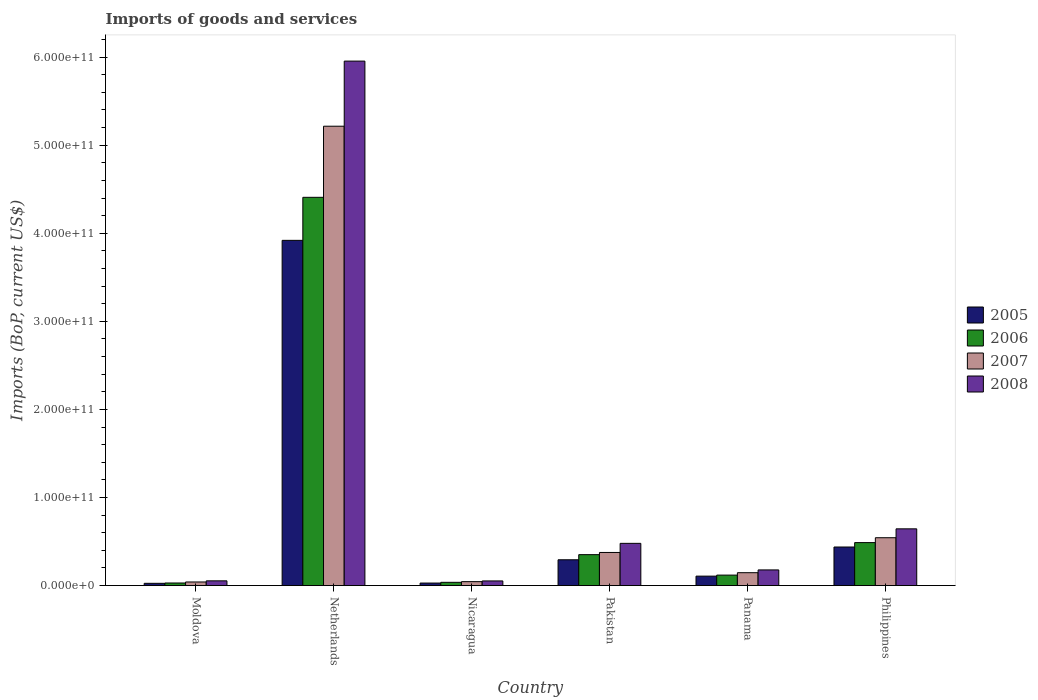How many different coloured bars are there?
Give a very brief answer. 4. How many groups of bars are there?
Make the answer very short. 6. Are the number of bars per tick equal to the number of legend labels?
Offer a terse response. Yes. How many bars are there on the 2nd tick from the left?
Keep it short and to the point. 4. What is the label of the 1st group of bars from the left?
Provide a short and direct response. Moldova. What is the amount spent on imports in 2008 in Panama?
Offer a very short reply. 1.78e+1. Across all countries, what is the maximum amount spent on imports in 2007?
Make the answer very short. 5.22e+11. Across all countries, what is the minimum amount spent on imports in 2006?
Provide a short and direct response. 2.93e+09. In which country was the amount spent on imports in 2008 minimum?
Provide a succinct answer. Nicaragua. What is the total amount spent on imports in 2008 in the graph?
Your response must be concise. 7.36e+11. What is the difference between the amount spent on imports in 2006 in Pakistan and that in Panama?
Keep it short and to the point. 2.32e+1. What is the difference between the amount spent on imports in 2006 in Philippines and the amount spent on imports in 2007 in Pakistan?
Ensure brevity in your answer.  1.12e+1. What is the average amount spent on imports in 2005 per country?
Your answer should be compact. 8.02e+1. What is the difference between the amount spent on imports of/in 2006 and amount spent on imports of/in 2007 in Pakistan?
Keep it short and to the point. -2.49e+09. In how many countries, is the amount spent on imports in 2005 greater than 20000000000 US$?
Offer a very short reply. 3. What is the ratio of the amount spent on imports in 2007 in Netherlands to that in Philippines?
Give a very brief answer. 9.6. Is the amount spent on imports in 2008 in Netherlands less than that in Philippines?
Make the answer very short. No. Is the difference between the amount spent on imports in 2006 in Netherlands and Nicaragua greater than the difference between the amount spent on imports in 2007 in Netherlands and Nicaragua?
Keep it short and to the point. No. What is the difference between the highest and the second highest amount spent on imports in 2008?
Give a very brief answer. 5.31e+11. What is the difference between the highest and the lowest amount spent on imports in 2006?
Your answer should be very brief. 4.38e+11. Is the sum of the amount spent on imports in 2005 in Moldova and Netherlands greater than the maximum amount spent on imports in 2008 across all countries?
Make the answer very short. No. Is it the case that in every country, the sum of the amount spent on imports in 2008 and amount spent on imports in 2005 is greater than the sum of amount spent on imports in 2006 and amount spent on imports in 2007?
Keep it short and to the point. No. What does the 3rd bar from the left in Philippines represents?
Your answer should be compact. 2007. What does the 4th bar from the right in Moldova represents?
Keep it short and to the point. 2005. Is it the case that in every country, the sum of the amount spent on imports in 2005 and amount spent on imports in 2007 is greater than the amount spent on imports in 2008?
Offer a terse response. Yes. How many bars are there?
Your answer should be compact. 24. How many countries are there in the graph?
Ensure brevity in your answer.  6. What is the difference between two consecutive major ticks on the Y-axis?
Offer a terse response. 1.00e+11. Are the values on the major ticks of Y-axis written in scientific E-notation?
Your response must be concise. Yes. Does the graph contain any zero values?
Your answer should be very brief. No. How many legend labels are there?
Provide a succinct answer. 4. How are the legend labels stacked?
Provide a succinct answer. Vertical. What is the title of the graph?
Make the answer very short. Imports of goods and services. What is the label or title of the X-axis?
Give a very brief answer. Country. What is the label or title of the Y-axis?
Provide a short and direct response. Imports (BoP, current US$). What is the Imports (BoP, current US$) of 2005 in Moldova?
Your answer should be compact. 2.54e+09. What is the Imports (BoP, current US$) of 2006 in Moldova?
Your response must be concise. 2.93e+09. What is the Imports (BoP, current US$) of 2007 in Moldova?
Offer a terse response. 4.07e+09. What is the Imports (BoP, current US$) in 2008 in Moldova?
Give a very brief answer. 5.37e+09. What is the Imports (BoP, current US$) in 2005 in Netherlands?
Ensure brevity in your answer.  3.92e+11. What is the Imports (BoP, current US$) in 2006 in Netherlands?
Offer a terse response. 4.41e+11. What is the Imports (BoP, current US$) in 2007 in Netherlands?
Your answer should be very brief. 5.22e+11. What is the Imports (BoP, current US$) of 2008 in Netherlands?
Make the answer very short. 5.95e+11. What is the Imports (BoP, current US$) in 2005 in Nicaragua?
Keep it short and to the point. 2.85e+09. What is the Imports (BoP, current US$) in 2006 in Nicaragua?
Offer a very short reply. 3.68e+09. What is the Imports (BoP, current US$) in 2007 in Nicaragua?
Provide a short and direct response. 4.45e+09. What is the Imports (BoP, current US$) of 2008 in Nicaragua?
Give a very brief answer. 5.26e+09. What is the Imports (BoP, current US$) in 2005 in Pakistan?
Make the answer very short. 2.93e+1. What is the Imports (BoP, current US$) in 2006 in Pakistan?
Your answer should be compact. 3.51e+1. What is the Imports (BoP, current US$) of 2007 in Pakistan?
Provide a succinct answer. 3.76e+1. What is the Imports (BoP, current US$) in 2008 in Pakistan?
Offer a terse response. 4.79e+1. What is the Imports (BoP, current US$) in 2005 in Panama?
Ensure brevity in your answer.  1.07e+1. What is the Imports (BoP, current US$) of 2006 in Panama?
Ensure brevity in your answer.  1.19e+1. What is the Imports (BoP, current US$) in 2007 in Panama?
Provide a succinct answer. 1.46e+1. What is the Imports (BoP, current US$) in 2008 in Panama?
Your answer should be compact. 1.78e+1. What is the Imports (BoP, current US$) in 2005 in Philippines?
Provide a succinct answer. 4.38e+1. What is the Imports (BoP, current US$) in 2006 in Philippines?
Your response must be concise. 4.88e+1. What is the Imports (BoP, current US$) in 2007 in Philippines?
Your answer should be compact. 5.43e+1. What is the Imports (BoP, current US$) in 2008 in Philippines?
Your answer should be very brief. 6.44e+1. Across all countries, what is the maximum Imports (BoP, current US$) of 2005?
Your answer should be compact. 3.92e+11. Across all countries, what is the maximum Imports (BoP, current US$) in 2006?
Provide a short and direct response. 4.41e+11. Across all countries, what is the maximum Imports (BoP, current US$) of 2007?
Give a very brief answer. 5.22e+11. Across all countries, what is the maximum Imports (BoP, current US$) of 2008?
Offer a very short reply. 5.95e+11. Across all countries, what is the minimum Imports (BoP, current US$) of 2005?
Offer a very short reply. 2.54e+09. Across all countries, what is the minimum Imports (BoP, current US$) of 2006?
Your response must be concise. 2.93e+09. Across all countries, what is the minimum Imports (BoP, current US$) of 2007?
Your answer should be compact. 4.07e+09. Across all countries, what is the minimum Imports (BoP, current US$) of 2008?
Ensure brevity in your answer.  5.26e+09. What is the total Imports (BoP, current US$) of 2005 in the graph?
Your response must be concise. 4.81e+11. What is the total Imports (BoP, current US$) of 2006 in the graph?
Provide a succinct answer. 5.43e+11. What is the total Imports (BoP, current US$) of 2007 in the graph?
Provide a short and direct response. 6.37e+11. What is the total Imports (BoP, current US$) of 2008 in the graph?
Your answer should be very brief. 7.36e+11. What is the difference between the Imports (BoP, current US$) of 2005 in Moldova and that in Netherlands?
Keep it short and to the point. -3.89e+11. What is the difference between the Imports (BoP, current US$) in 2006 in Moldova and that in Netherlands?
Your response must be concise. -4.38e+11. What is the difference between the Imports (BoP, current US$) of 2007 in Moldova and that in Netherlands?
Your answer should be compact. -5.17e+11. What is the difference between the Imports (BoP, current US$) of 2008 in Moldova and that in Netherlands?
Offer a terse response. -5.90e+11. What is the difference between the Imports (BoP, current US$) of 2005 in Moldova and that in Nicaragua?
Give a very brief answer. -3.08e+08. What is the difference between the Imports (BoP, current US$) of 2006 in Moldova and that in Nicaragua?
Ensure brevity in your answer.  -7.55e+08. What is the difference between the Imports (BoP, current US$) of 2007 in Moldova and that in Nicaragua?
Offer a very short reply. -3.85e+08. What is the difference between the Imports (BoP, current US$) in 2008 in Moldova and that in Nicaragua?
Provide a succinct answer. 1.14e+08. What is the difference between the Imports (BoP, current US$) in 2005 in Moldova and that in Pakistan?
Your answer should be very brief. -2.67e+1. What is the difference between the Imports (BoP, current US$) in 2006 in Moldova and that in Pakistan?
Keep it short and to the point. -3.22e+1. What is the difference between the Imports (BoP, current US$) of 2007 in Moldova and that in Pakistan?
Your answer should be very brief. -3.35e+1. What is the difference between the Imports (BoP, current US$) in 2008 in Moldova and that in Pakistan?
Offer a very short reply. -4.26e+1. What is the difference between the Imports (BoP, current US$) of 2005 in Moldova and that in Panama?
Your answer should be compact. -8.16e+09. What is the difference between the Imports (BoP, current US$) of 2006 in Moldova and that in Panama?
Offer a terse response. -8.96e+09. What is the difference between the Imports (BoP, current US$) of 2007 in Moldova and that in Panama?
Provide a succinct answer. -1.05e+1. What is the difference between the Imports (BoP, current US$) of 2008 in Moldova and that in Panama?
Ensure brevity in your answer.  -1.24e+1. What is the difference between the Imports (BoP, current US$) of 2005 in Moldova and that in Philippines?
Offer a very short reply. -4.12e+1. What is the difference between the Imports (BoP, current US$) in 2006 in Moldova and that in Philippines?
Your answer should be compact. -4.59e+1. What is the difference between the Imports (BoP, current US$) in 2007 in Moldova and that in Philippines?
Offer a terse response. -5.02e+1. What is the difference between the Imports (BoP, current US$) of 2008 in Moldova and that in Philippines?
Your response must be concise. -5.90e+1. What is the difference between the Imports (BoP, current US$) of 2005 in Netherlands and that in Nicaragua?
Provide a short and direct response. 3.89e+11. What is the difference between the Imports (BoP, current US$) in 2006 in Netherlands and that in Nicaragua?
Keep it short and to the point. 4.37e+11. What is the difference between the Imports (BoP, current US$) in 2007 in Netherlands and that in Nicaragua?
Give a very brief answer. 5.17e+11. What is the difference between the Imports (BoP, current US$) of 2008 in Netherlands and that in Nicaragua?
Offer a very short reply. 5.90e+11. What is the difference between the Imports (BoP, current US$) of 2005 in Netherlands and that in Pakistan?
Your answer should be compact. 3.63e+11. What is the difference between the Imports (BoP, current US$) of 2006 in Netherlands and that in Pakistan?
Provide a short and direct response. 4.06e+11. What is the difference between the Imports (BoP, current US$) in 2007 in Netherlands and that in Pakistan?
Ensure brevity in your answer.  4.84e+11. What is the difference between the Imports (BoP, current US$) of 2008 in Netherlands and that in Pakistan?
Ensure brevity in your answer.  5.48e+11. What is the difference between the Imports (BoP, current US$) of 2005 in Netherlands and that in Panama?
Offer a very short reply. 3.81e+11. What is the difference between the Imports (BoP, current US$) of 2006 in Netherlands and that in Panama?
Make the answer very short. 4.29e+11. What is the difference between the Imports (BoP, current US$) of 2007 in Netherlands and that in Panama?
Your answer should be very brief. 5.07e+11. What is the difference between the Imports (BoP, current US$) in 2008 in Netherlands and that in Panama?
Provide a succinct answer. 5.78e+11. What is the difference between the Imports (BoP, current US$) in 2005 in Netherlands and that in Philippines?
Your answer should be very brief. 3.48e+11. What is the difference between the Imports (BoP, current US$) in 2006 in Netherlands and that in Philippines?
Make the answer very short. 3.92e+11. What is the difference between the Imports (BoP, current US$) of 2007 in Netherlands and that in Philippines?
Your answer should be very brief. 4.67e+11. What is the difference between the Imports (BoP, current US$) of 2008 in Netherlands and that in Philippines?
Your response must be concise. 5.31e+11. What is the difference between the Imports (BoP, current US$) in 2005 in Nicaragua and that in Pakistan?
Offer a terse response. -2.64e+1. What is the difference between the Imports (BoP, current US$) in 2006 in Nicaragua and that in Pakistan?
Make the answer very short. -3.14e+1. What is the difference between the Imports (BoP, current US$) of 2007 in Nicaragua and that in Pakistan?
Provide a short and direct response. -3.31e+1. What is the difference between the Imports (BoP, current US$) in 2008 in Nicaragua and that in Pakistan?
Keep it short and to the point. -4.27e+1. What is the difference between the Imports (BoP, current US$) of 2005 in Nicaragua and that in Panama?
Offer a very short reply. -7.85e+09. What is the difference between the Imports (BoP, current US$) in 2006 in Nicaragua and that in Panama?
Give a very brief answer. -8.20e+09. What is the difference between the Imports (BoP, current US$) of 2007 in Nicaragua and that in Panama?
Offer a terse response. -1.02e+1. What is the difference between the Imports (BoP, current US$) of 2008 in Nicaragua and that in Panama?
Give a very brief answer. -1.25e+1. What is the difference between the Imports (BoP, current US$) of 2005 in Nicaragua and that in Philippines?
Keep it short and to the point. -4.09e+1. What is the difference between the Imports (BoP, current US$) in 2006 in Nicaragua and that in Philippines?
Keep it short and to the point. -4.51e+1. What is the difference between the Imports (BoP, current US$) of 2007 in Nicaragua and that in Philippines?
Your answer should be compact. -4.99e+1. What is the difference between the Imports (BoP, current US$) in 2008 in Nicaragua and that in Philippines?
Your answer should be very brief. -5.92e+1. What is the difference between the Imports (BoP, current US$) in 2005 in Pakistan and that in Panama?
Provide a short and direct response. 1.86e+1. What is the difference between the Imports (BoP, current US$) in 2006 in Pakistan and that in Panama?
Provide a succinct answer. 2.32e+1. What is the difference between the Imports (BoP, current US$) in 2007 in Pakistan and that in Panama?
Make the answer very short. 2.30e+1. What is the difference between the Imports (BoP, current US$) in 2008 in Pakistan and that in Panama?
Offer a very short reply. 3.02e+1. What is the difference between the Imports (BoP, current US$) in 2005 in Pakistan and that in Philippines?
Your answer should be very brief. -1.45e+1. What is the difference between the Imports (BoP, current US$) in 2006 in Pakistan and that in Philippines?
Your answer should be very brief. -1.37e+1. What is the difference between the Imports (BoP, current US$) of 2007 in Pakistan and that in Philippines?
Your response must be concise. -1.67e+1. What is the difference between the Imports (BoP, current US$) of 2008 in Pakistan and that in Philippines?
Give a very brief answer. -1.65e+1. What is the difference between the Imports (BoP, current US$) of 2005 in Panama and that in Philippines?
Provide a short and direct response. -3.31e+1. What is the difference between the Imports (BoP, current US$) in 2006 in Panama and that in Philippines?
Offer a very short reply. -3.69e+1. What is the difference between the Imports (BoP, current US$) of 2007 in Panama and that in Philippines?
Your response must be concise. -3.97e+1. What is the difference between the Imports (BoP, current US$) of 2008 in Panama and that in Philippines?
Your answer should be compact. -4.67e+1. What is the difference between the Imports (BoP, current US$) of 2005 in Moldova and the Imports (BoP, current US$) of 2006 in Netherlands?
Your answer should be compact. -4.38e+11. What is the difference between the Imports (BoP, current US$) in 2005 in Moldova and the Imports (BoP, current US$) in 2007 in Netherlands?
Your answer should be very brief. -5.19e+11. What is the difference between the Imports (BoP, current US$) in 2005 in Moldova and the Imports (BoP, current US$) in 2008 in Netherlands?
Provide a short and direct response. -5.93e+11. What is the difference between the Imports (BoP, current US$) in 2006 in Moldova and the Imports (BoP, current US$) in 2007 in Netherlands?
Provide a succinct answer. -5.19e+11. What is the difference between the Imports (BoP, current US$) in 2006 in Moldova and the Imports (BoP, current US$) in 2008 in Netherlands?
Give a very brief answer. -5.93e+11. What is the difference between the Imports (BoP, current US$) of 2007 in Moldova and the Imports (BoP, current US$) of 2008 in Netherlands?
Your response must be concise. -5.91e+11. What is the difference between the Imports (BoP, current US$) in 2005 in Moldova and the Imports (BoP, current US$) in 2006 in Nicaragua?
Provide a short and direct response. -1.14e+09. What is the difference between the Imports (BoP, current US$) in 2005 in Moldova and the Imports (BoP, current US$) in 2007 in Nicaragua?
Provide a succinct answer. -1.91e+09. What is the difference between the Imports (BoP, current US$) of 2005 in Moldova and the Imports (BoP, current US$) of 2008 in Nicaragua?
Make the answer very short. -2.71e+09. What is the difference between the Imports (BoP, current US$) of 2006 in Moldova and the Imports (BoP, current US$) of 2007 in Nicaragua?
Your answer should be very brief. -1.53e+09. What is the difference between the Imports (BoP, current US$) in 2006 in Moldova and the Imports (BoP, current US$) in 2008 in Nicaragua?
Offer a very short reply. -2.33e+09. What is the difference between the Imports (BoP, current US$) of 2007 in Moldova and the Imports (BoP, current US$) of 2008 in Nicaragua?
Provide a succinct answer. -1.19e+09. What is the difference between the Imports (BoP, current US$) of 2005 in Moldova and the Imports (BoP, current US$) of 2006 in Pakistan?
Your answer should be very brief. -3.26e+1. What is the difference between the Imports (BoP, current US$) of 2005 in Moldova and the Imports (BoP, current US$) of 2007 in Pakistan?
Keep it short and to the point. -3.50e+1. What is the difference between the Imports (BoP, current US$) of 2005 in Moldova and the Imports (BoP, current US$) of 2008 in Pakistan?
Provide a succinct answer. -4.54e+1. What is the difference between the Imports (BoP, current US$) of 2006 in Moldova and the Imports (BoP, current US$) of 2007 in Pakistan?
Offer a terse response. -3.47e+1. What is the difference between the Imports (BoP, current US$) of 2006 in Moldova and the Imports (BoP, current US$) of 2008 in Pakistan?
Provide a succinct answer. -4.50e+1. What is the difference between the Imports (BoP, current US$) of 2007 in Moldova and the Imports (BoP, current US$) of 2008 in Pakistan?
Give a very brief answer. -4.39e+1. What is the difference between the Imports (BoP, current US$) in 2005 in Moldova and the Imports (BoP, current US$) in 2006 in Panama?
Ensure brevity in your answer.  -9.34e+09. What is the difference between the Imports (BoP, current US$) of 2005 in Moldova and the Imports (BoP, current US$) of 2007 in Panama?
Your response must be concise. -1.21e+1. What is the difference between the Imports (BoP, current US$) of 2005 in Moldova and the Imports (BoP, current US$) of 2008 in Panama?
Offer a very short reply. -1.52e+1. What is the difference between the Imports (BoP, current US$) of 2006 in Moldova and the Imports (BoP, current US$) of 2007 in Panama?
Provide a short and direct response. -1.17e+1. What is the difference between the Imports (BoP, current US$) of 2006 in Moldova and the Imports (BoP, current US$) of 2008 in Panama?
Keep it short and to the point. -1.48e+1. What is the difference between the Imports (BoP, current US$) of 2007 in Moldova and the Imports (BoP, current US$) of 2008 in Panama?
Ensure brevity in your answer.  -1.37e+1. What is the difference between the Imports (BoP, current US$) in 2005 in Moldova and the Imports (BoP, current US$) in 2006 in Philippines?
Your answer should be very brief. -4.62e+1. What is the difference between the Imports (BoP, current US$) in 2005 in Moldova and the Imports (BoP, current US$) in 2007 in Philippines?
Your answer should be compact. -5.18e+1. What is the difference between the Imports (BoP, current US$) of 2005 in Moldova and the Imports (BoP, current US$) of 2008 in Philippines?
Provide a succinct answer. -6.19e+1. What is the difference between the Imports (BoP, current US$) of 2006 in Moldova and the Imports (BoP, current US$) of 2007 in Philippines?
Provide a short and direct response. -5.14e+1. What is the difference between the Imports (BoP, current US$) of 2006 in Moldova and the Imports (BoP, current US$) of 2008 in Philippines?
Keep it short and to the point. -6.15e+1. What is the difference between the Imports (BoP, current US$) in 2007 in Moldova and the Imports (BoP, current US$) in 2008 in Philippines?
Make the answer very short. -6.03e+1. What is the difference between the Imports (BoP, current US$) of 2005 in Netherlands and the Imports (BoP, current US$) of 2006 in Nicaragua?
Provide a succinct answer. 3.88e+11. What is the difference between the Imports (BoP, current US$) of 2005 in Netherlands and the Imports (BoP, current US$) of 2007 in Nicaragua?
Offer a very short reply. 3.87e+11. What is the difference between the Imports (BoP, current US$) in 2005 in Netherlands and the Imports (BoP, current US$) in 2008 in Nicaragua?
Offer a terse response. 3.87e+11. What is the difference between the Imports (BoP, current US$) of 2006 in Netherlands and the Imports (BoP, current US$) of 2007 in Nicaragua?
Provide a succinct answer. 4.36e+11. What is the difference between the Imports (BoP, current US$) of 2006 in Netherlands and the Imports (BoP, current US$) of 2008 in Nicaragua?
Offer a terse response. 4.36e+11. What is the difference between the Imports (BoP, current US$) of 2007 in Netherlands and the Imports (BoP, current US$) of 2008 in Nicaragua?
Provide a succinct answer. 5.16e+11. What is the difference between the Imports (BoP, current US$) in 2005 in Netherlands and the Imports (BoP, current US$) in 2006 in Pakistan?
Your answer should be compact. 3.57e+11. What is the difference between the Imports (BoP, current US$) of 2005 in Netherlands and the Imports (BoP, current US$) of 2007 in Pakistan?
Provide a succinct answer. 3.54e+11. What is the difference between the Imports (BoP, current US$) in 2005 in Netherlands and the Imports (BoP, current US$) in 2008 in Pakistan?
Your answer should be compact. 3.44e+11. What is the difference between the Imports (BoP, current US$) in 2006 in Netherlands and the Imports (BoP, current US$) in 2007 in Pakistan?
Provide a short and direct response. 4.03e+11. What is the difference between the Imports (BoP, current US$) in 2006 in Netherlands and the Imports (BoP, current US$) in 2008 in Pakistan?
Your response must be concise. 3.93e+11. What is the difference between the Imports (BoP, current US$) of 2007 in Netherlands and the Imports (BoP, current US$) of 2008 in Pakistan?
Provide a short and direct response. 4.74e+11. What is the difference between the Imports (BoP, current US$) in 2005 in Netherlands and the Imports (BoP, current US$) in 2006 in Panama?
Offer a terse response. 3.80e+11. What is the difference between the Imports (BoP, current US$) of 2005 in Netherlands and the Imports (BoP, current US$) of 2007 in Panama?
Offer a very short reply. 3.77e+11. What is the difference between the Imports (BoP, current US$) in 2005 in Netherlands and the Imports (BoP, current US$) in 2008 in Panama?
Your response must be concise. 3.74e+11. What is the difference between the Imports (BoP, current US$) in 2006 in Netherlands and the Imports (BoP, current US$) in 2007 in Panama?
Keep it short and to the point. 4.26e+11. What is the difference between the Imports (BoP, current US$) in 2006 in Netherlands and the Imports (BoP, current US$) in 2008 in Panama?
Your response must be concise. 4.23e+11. What is the difference between the Imports (BoP, current US$) in 2007 in Netherlands and the Imports (BoP, current US$) in 2008 in Panama?
Offer a very short reply. 5.04e+11. What is the difference between the Imports (BoP, current US$) of 2005 in Netherlands and the Imports (BoP, current US$) of 2006 in Philippines?
Provide a short and direct response. 3.43e+11. What is the difference between the Imports (BoP, current US$) of 2005 in Netherlands and the Imports (BoP, current US$) of 2007 in Philippines?
Keep it short and to the point. 3.38e+11. What is the difference between the Imports (BoP, current US$) in 2005 in Netherlands and the Imports (BoP, current US$) in 2008 in Philippines?
Make the answer very short. 3.28e+11. What is the difference between the Imports (BoP, current US$) of 2006 in Netherlands and the Imports (BoP, current US$) of 2007 in Philippines?
Provide a short and direct response. 3.86e+11. What is the difference between the Imports (BoP, current US$) in 2006 in Netherlands and the Imports (BoP, current US$) in 2008 in Philippines?
Your response must be concise. 3.76e+11. What is the difference between the Imports (BoP, current US$) in 2007 in Netherlands and the Imports (BoP, current US$) in 2008 in Philippines?
Your answer should be very brief. 4.57e+11. What is the difference between the Imports (BoP, current US$) in 2005 in Nicaragua and the Imports (BoP, current US$) in 2006 in Pakistan?
Provide a short and direct response. -3.22e+1. What is the difference between the Imports (BoP, current US$) in 2005 in Nicaragua and the Imports (BoP, current US$) in 2007 in Pakistan?
Your answer should be very brief. -3.47e+1. What is the difference between the Imports (BoP, current US$) of 2005 in Nicaragua and the Imports (BoP, current US$) of 2008 in Pakistan?
Give a very brief answer. -4.51e+1. What is the difference between the Imports (BoP, current US$) of 2006 in Nicaragua and the Imports (BoP, current US$) of 2007 in Pakistan?
Make the answer very short. -3.39e+1. What is the difference between the Imports (BoP, current US$) of 2006 in Nicaragua and the Imports (BoP, current US$) of 2008 in Pakistan?
Keep it short and to the point. -4.42e+1. What is the difference between the Imports (BoP, current US$) of 2007 in Nicaragua and the Imports (BoP, current US$) of 2008 in Pakistan?
Give a very brief answer. -4.35e+1. What is the difference between the Imports (BoP, current US$) in 2005 in Nicaragua and the Imports (BoP, current US$) in 2006 in Panama?
Offer a terse response. -9.03e+09. What is the difference between the Imports (BoP, current US$) of 2005 in Nicaragua and the Imports (BoP, current US$) of 2007 in Panama?
Your response must be concise. -1.18e+1. What is the difference between the Imports (BoP, current US$) of 2005 in Nicaragua and the Imports (BoP, current US$) of 2008 in Panama?
Your answer should be compact. -1.49e+1. What is the difference between the Imports (BoP, current US$) in 2006 in Nicaragua and the Imports (BoP, current US$) in 2007 in Panama?
Your answer should be very brief. -1.09e+1. What is the difference between the Imports (BoP, current US$) in 2006 in Nicaragua and the Imports (BoP, current US$) in 2008 in Panama?
Offer a terse response. -1.41e+1. What is the difference between the Imports (BoP, current US$) of 2007 in Nicaragua and the Imports (BoP, current US$) of 2008 in Panama?
Offer a very short reply. -1.33e+1. What is the difference between the Imports (BoP, current US$) in 2005 in Nicaragua and the Imports (BoP, current US$) in 2006 in Philippines?
Ensure brevity in your answer.  -4.59e+1. What is the difference between the Imports (BoP, current US$) of 2005 in Nicaragua and the Imports (BoP, current US$) of 2007 in Philippines?
Provide a succinct answer. -5.15e+1. What is the difference between the Imports (BoP, current US$) of 2005 in Nicaragua and the Imports (BoP, current US$) of 2008 in Philippines?
Provide a short and direct response. -6.16e+1. What is the difference between the Imports (BoP, current US$) in 2006 in Nicaragua and the Imports (BoP, current US$) in 2007 in Philippines?
Provide a succinct answer. -5.06e+1. What is the difference between the Imports (BoP, current US$) in 2006 in Nicaragua and the Imports (BoP, current US$) in 2008 in Philippines?
Offer a terse response. -6.07e+1. What is the difference between the Imports (BoP, current US$) of 2007 in Nicaragua and the Imports (BoP, current US$) of 2008 in Philippines?
Provide a succinct answer. -6.00e+1. What is the difference between the Imports (BoP, current US$) in 2005 in Pakistan and the Imports (BoP, current US$) in 2006 in Panama?
Provide a succinct answer. 1.74e+1. What is the difference between the Imports (BoP, current US$) in 2005 in Pakistan and the Imports (BoP, current US$) in 2007 in Panama?
Provide a short and direct response. 1.47e+1. What is the difference between the Imports (BoP, current US$) of 2005 in Pakistan and the Imports (BoP, current US$) of 2008 in Panama?
Your answer should be very brief. 1.15e+1. What is the difference between the Imports (BoP, current US$) of 2006 in Pakistan and the Imports (BoP, current US$) of 2007 in Panama?
Your answer should be very brief. 2.05e+1. What is the difference between the Imports (BoP, current US$) of 2006 in Pakistan and the Imports (BoP, current US$) of 2008 in Panama?
Make the answer very short. 1.73e+1. What is the difference between the Imports (BoP, current US$) of 2007 in Pakistan and the Imports (BoP, current US$) of 2008 in Panama?
Give a very brief answer. 1.98e+1. What is the difference between the Imports (BoP, current US$) of 2005 in Pakistan and the Imports (BoP, current US$) of 2006 in Philippines?
Make the answer very short. -1.95e+1. What is the difference between the Imports (BoP, current US$) of 2005 in Pakistan and the Imports (BoP, current US$) of 2007 in Philippines?
Ensure brevity in your answer.  -2.50e+1. What is the difference between the Imports (BoP, current US$) in 2005 in Pakistan and the Imports (BoP, current US$) in 2008 in Philippines?
Give a very brief answer. -3.51e+1. What is the difference between the Imports (BoP, current US$) in 2006 in Pakistan and the Imports (BoP, current US$) in 2007 in Philippines?
Your response must be concise. -1.92e+1. What is the difference between the Imports (BoP, current US$) in 2006 in Pakistan and the Imports (BoP, current US$) in 2008 in Philippines?
Make the answer very short. -2.93e+1. What is the difference between the Imports (BoP, current US$) of 2007 in Pakistan and the Imports (BoP, current US$) of 2008 in Philippines?
Make the answer very short. -2.68e+1. What is the difference between the Imports (BoP, current US$) of 2005 in Panama and the Imports (BoP, current US$) of 2006 in Philippines?
Provide a succinct answer. -3.81e+1. What is the difference between the Imports (BoP, current US$) of 2005 in Panama and the Imports (BoP, current US$) of 2007 in Philippines?
Your answer should be very brief. -4.36e+1. What is the difference between the Imports (BoP, current US$) of 2005 in Panama and the Imports (BoP, current US$) of 2008 in Philippines?
Your response must be concise. -5.37e+1. What is the difference between the Imports (BoP, current US$) of 2006 in Panama and the Imports (BoP, current US$) of 2007 in Philippines?
Keep it short and to the point. -4.24e+1. What is the difference between the Imports (BoP, current US$) in 2006 in Panama and the Imports (BoP, current US$) in 2008 in Philippines?
Ensure brevity in your answer.  -5.25e+1. What is the difference between the Imports (BoP, current US$) of 2007 in Panama and the Imports (BoP, current US$) of 2008 in Philippines?
Provide a short and direct response. -4.98e+1. What is the average Imports (BoP, current US$) in 2005 per country?
Provide a short and direct response. 8.02e+1. What is the average Imports (BoP, current US$) of 2006 per country?
Make the answer very short. 9.05e+1. What is the average Imports (BoP, current US$) in 2007 per country?
Provide a short and direct response. 1.06e+11. What is the average Imports (BoP, current US$) in 2008 per country?
Give a very brief answer. 1.23e+11. What is the difference between the Imports (BoP, current US$) of 2005 and Imports (BoP, current US$) of 2006 in Moldova?
Ensure brevity in your answer.  -3.81e+08. What is the difference between the Imports (BoP, current US$) of 2005 and Imports (BoP, current US$) of 2007 in Moldova?
Your answer should be very brief. -1.52e+09. What is the difference between the Imports (BoP, current US$) of 2005 and Imports (BoP, current US$) of 2008 in Moldova?
Offer a terse response. -2.82e+09. What is the difference between the Imports (BoP, current US$) of 2006 and Imports (BoP, current US$) of 2007 in Moldova?
Your answer should be very brief. -1.14e+09. What is the difference between the Imports (BoP, current US$) of 2006 and Imports (BoP, current US$) of 2008 in Moldova?
Offer a very short reply. -2.44e+09. What is the difference between the Imports (BoP, current US$) in 2007 and Imports (BoP, current US$) in 2008 in Moldova?
Provide a succinct answer. -1.30e+09. What is the difference between the Imports (BoP, current US$) in 2005 and Imports (BoP, current US$) in 2006 in Netherlands?
Ensure brevity in your answer.  -4.88e+1. What is the difference between the Imports (BoP, current US$) in 2005 and Imports (BoP, current US$) in 2007 in Netherlands?
Give a very brief answer. -1.30e+11. What is the difference between the Imports (BoP, current US$) in 2005 and Imports (BoP, current US$) in 2008 in Netherlands?
Give a very brief answer. -2.04e+11. What is the difference between the Imports (BoP, current US$) in 2006 and Imports (BoP, current US$) in 2007 in Netherlands?
Provide a short and direct response. -8.07e+1. What is the difference between the Imports (BoP, current US$) of 2006 and Imports (BoP, current US$) of 2008 in Netherlands?
Give a very brief answer. -1.55e+11. What is the difference between the Imports (BoP, current US$) of 2007 and Imports (BoP, current US$) of 2008 in Netherlands?
Offer a very short reply. -7.39e+1. What is the difference between the Imports (BoP, current US$) in 2005 and Imports (BoP, current US$) in 2006 in Nicaragua?
Provide a short and direct response. -8.28e+08. What is the difference between the Imports (BoP, current US$) in 2005 and Imports (BoP, current US$) in 2007 in Nicaragua?
Give a very brief answer. -1.60e+09. What is the difference between the Imports (BoP, current US$) of 2005 and Imports (BoP, current US$) of 2008 in Nicaragua?
Make the answer very short. -2.40e+09. What is the difference between the Imports (BoP, current US$) of 2006 and Imports (BoP, current US$) of 2007 in Nicaragua?
Provide a short and direct response. -7.70e+08. What is the difference between the Imports (BoP, current US$) of 2006 and Imports (BoP, current US$) of 2008 in Nicaragua?
Ensure brevity in your answer.  -1.57e+09. What is the difference between the Imports (BoP, current US$) in 2007 and Imports (BoP, current US$) in 2008 in Nicaragua?
Offer a very short reply. -8.05e+08. What is the difference between the Imports (BoP, current US$) of 2005 and Imports (BoP, current US$) of 2006 in Pakistan?
Make the answer very short. -5.83e+09. What is the difference between the Imports (BoP, current US$) of 2005 and Imports (BoP, current US$) of 2007 in Pakistan?
Provide a short and direct response. -8.31e+09. What is the difference between the Imports (BoP, current US$) in 2005 and Imports (BoP, current US$) in 2008 in Pakistan?
Give a very brief answer. -1.87e+1. What is the difference between the Imports (BoP, current US$) of 2006 and Imports (BoP, current US$) of 2007 in Pakistan?
Provide a short and direct response. -2.49e+09. What is the difference between the Imports (BoP, current US$) in 2006 and Imports (BoP, current US$) in 2008 in Pakistan?
Keep it short and to the point. -1.28e+1. What is the difference between the Imports (BoP, current US$) in 2007 and Imports (BoP, current US$) in 2008 in Pakistan?
Your response must be concise. -1.03e+1. What is the difference between the Imports (BoP, current US$) in 2005 and Imports (BoP, current US$) in 2006 in Panama?
Give a very brief answer. -1.18e+09. What is the difference between the Imports (BoP, current US$) of 2005 and Imports (BoP, current US$) of 2007 in Panama?
Make the answer very short. -3.91e+09. What is the difference between the Imports (BoP, current US$) of 2005 and Imports (BoP, current US$) of 2008 in Panama?
Ensure brevity in your answer.  -7.06e+09. What is the difference between the Imports (BoP, current US$) of 2006 and Imports (BoP, current US$) of 2007 in Panama?
Give a very brief answer. -2.73e+09. What is the difference between the Imports (BoP, current US$) of 2006 and Imports (BoP, current US$) of 2008 in Panama?
Provide a short and direct response. -5.87e+09. What is the difference between the Imports (BoP, current US$) of 2007 and Imports (BoP, current US$) of 2008 in Panama?
Your answer should be compact. -3.14e+09. What is the difference between the Imports (BoP, current US$) in 2005 and Imports (BoP, current US$) in 2006 in Philippines?
Your answer should be very brief. -5.01e+09. What is the difference between the Imports (BoP, current US$) of 2005 and Imports (BoP, current US$) of 2007 in Philippines?
Provide a succinct answer. -1.05e+1. What is the difference between the Imports (BoP, current US$) of 2005 and Imports (BoP, current US$) of 2008 in Philippines?
Keep it short and to the point. -2.06e+1. What is the difference between the Imports (BoP, current US$) of 2006 and Imports (BoP, current US$) of 2007 in Philippines?
Provide a succinct answer. -5.53e+09. What is the difference between the Imports (BoP, current US$) of 2006 and Imports (BoP, current US$) of 2008 in Philippines?
Offer a very short reply. -1.56e+1. What is the difference between the Imports (BoP, current US$) of 2007 and Imports (BoP, current US$) of 2008 in Philippines?
Ensure brevity in your answer.  -1.01e+1. What is the ratio of the Imports (BoP, current US$) of 2005 in Moldova to that in Netherlands?
Your answer should be very brief. 0.01. What is the ratio of the Imports (BoP, current US$) in 2006 in Moldova to that in Netherlands?
Ensure brevity in your answer.  0.01. What is the ratio of the Imports (BoP, current US$) in 2007 in Moldova to that in Netherlands?
Ensure brevity in your answer.  0.01. What is the ratio of the Imports (BoP, current US$) of 2008 in Moldova to that in Netherlands?
Provide a succinct answer. 0.01. What is the ratio of the Imports (BoP, current US$) in 2005 in Moldova to that in Nicaragua?
Offer a terse response. 0.89. What is the ratio of the Imports (BoP, current US$) of 2006 in Moldova to that in Nicaragua?
Make the answer very short. 0.79. What is the ratio of the Imports (BoP, current US$) of 2007 in Moldova to that in Nicaragua?
Make the answer very short. 0.91. What is the ratio of the Imports (BoP, current US$) in 2008 in Moldova to that in Nicaragua?
Your answer should be compact. 1.02. What is the ratio of the Imports (BoP, current US$) of 2005 in Moldova to that in Pakistan?
Give a very brief answer. 0.09. What is the ratio of the Imports (BoP, current US$) of 2006 in Moldova to that in Pakistan?
Offer a terse response. 0.08. What is the ratio of the Imports (BoP, current US$) of 2007 in Moldova to that in Pakistan?
Offer a terse response. 0.11. What is the ratio of the Imports (BoP, current US$) in 2008 in Moldova to that in Pakistan?
Offer a terse response. 0.11. What is the ratio of the Imports (BoP, current US$) in 2005 in Moldova to that in Panama?
Ensure brevity in your answer.  0.24. What is the ratio of the Imports (BoP, current US$) of 2006 in Moldova to that in Panama?
Keep it short and to the point. 0.25. What is the ratio of the Imports (BoP, current US$) of 2007 in Moldova to that in Panama?
Ensure brevity in your answer.  0.28. What is the ratio of the Imports (BoP, current US$) of 2008 in Moldova to that in Panama?
Your answer should be very brief. 0.3. What is the ratio of the Imports (BoP, current US$) in 2005 in Moldova to that in Philippines?
Make the answer very short. 0.06. What is the ratio of the Imports (BoP, current US$) in 2007 in Moldova to that in Philippines?
Your response must be concise. 0.07. What is the ratio of the Imports (BoP, current US$) in 2008 in Moldova to that in Philippines?
Provide a short and direct response. 0.08. What is the ratio of the Imports (BoP, current US$) in 2005 in Netherlands to that in Nicaragua?
Give a very brief answer. 137.38. What is the ratio of the Imports (BoP, current US$) of 2006 in Netherlands to that in Nicaragua?
Ensure brevity in your answer.  119.75. What is the ratio of the Imports (BoP, current US$) of 2007 in Netherlands to that in Nicaragua?
Your response must be concise. 117.17. What is the ratio of the Imports (BoP, current US$) in 2008 in Netherlands to that in Nicaragua?
Your response must be concise. 113.3. What is the ratio of the Imports (BoP, current US$) of 2005 in Netherlands to that in Pakistan?
Provide a short and direct response. 13.39. What is the ratio of the Imports (BoP, current US$) of 2006 in Netherlands to that in Pakistan?
Your answer should be compact. 12.56. What is the ratio of the Imports (BoP, current US$) in 2007 in Netherlands to that in Pakistan?
Ensure brevity in your answer.  13.88. What is the ratio of the Imports (BoP, current US$) of 2008 in Netherlands to that in Pakistan?
Offer a terse response. 12.42. What is the ratio of the Imports (BoP, current US$) in 2005 in Netherlands to that in Panama?
Your response must be concise. 36.62. What is the ratio of the Imports (BoP, current US$) of 2006 in Netherlands to that in Panama?
Offer a very short reply. 37.08. What is the ratio of the Imports (BoP, current US$) in 2007 in Netherlands to that in Panama?
Offer a terse response. 35.69. What is the ratio of the Imports (BoP, current US$) of 2008 in Netherlands to that in Panama?
Your answer should be compact. 33.53. What is the ratio of the Imports (BoP, current US$) in 2005 in Netherlands to that in Philippines?
Your response must be concise. 8.95. What is the ratio of the Imports (BoP, current US$) of 2006 in Netherlands to that in Philippines?
Provide a short and direct response. 9.04. What is the ratio of the Imports (BoP, current US$) of 2007 in Netherlands to that in Philippines?
Your response must be concise. 9.6. What is the ratio of the Imports (BoP, current US$) in 2008 in Netherlands to that in Philippines?
Your answer should be very brief. 9.24. What is the ratio of the Imports (BoP, current US$) in 2005 in Nicaragua to that in Pakistan?
Offer a very short reply. 0.1. What is the ratio of the Imports (BoP, current US$) in 2006 in Nicaragua to that in Pakistan?
Offer a very short reply. 0.1. What is the ratio of the Imports (BoP, current US$) in 2007 in Nicaragua to that in Pakistan?
Your answer should be very brief. 0.12. What is the ratio of the Imports (BoP, current US$) of 2008 in Nicaragua to that in Pakistan?
Give a very brief answer. 0.11. What is the ratio of the Imports (BoP, current US$) of 2005 in Nicaragua to that in Panama?
Provide a short and direct response. 0.27. What is the ratio of the Imports (BoP, current US$) of 2006 in Nicaragua to that in Panama?
Keep it short and to the point. 0.31. What is the ratio of the Imports (BoP, current US$) of 2007 in Nicaragua to that in Panama?
Your answer should be compact. 0.3. What is the ratio of the Imports (BoP, current US$) in 2008 in Nicaragua to that in Panama?
Provide a succinct answer. 0.3. What is the ratio of the Imports (BoP, current US$) in 2005 in Nicaragua to that in Philippines?
Your answer should be compact. 0.07. What is the ratio of the Imports (BoP, current US$) in 2006 in Nicaragua to that in Philippines?
Ensure brevity in your answer.  0.08. What is the ratio of the Imports (BoP, current US$) in 2007 in Nicaragua to that in Philippines?
Offer a very short reply. 0.08. What is the ratio of the Imports (BoP, current US$) of 2008 in Nicaragua to that in Philippines?
Your answer should be compact. 0.08. What is the ratio of the Imports (BoP, current US$) in 2005 in Pakistan to that in Panama?
Give a very brief answer. 2.74. What is the ratio of the Imports (BoP, current US$) of 2006 in Pakistan to that in Panama?
Keep it short and to the point. 2.95. What is the ratio of the Imports (BoP, current US$) of 2007 in Pakistan to that in Panama?
Keep it short and to the point. 2.57. What is the ratio of the Imports (BoP, current US$) of 2008 in Pakistan to that in Panama?
Keep it short and to the point. 2.7. What is the ratio of the Imports (BoP, current US$) of 2005 in Pakistan to that in Philippines?
Ensure brevity in your answer.  0.67. What is the ratio of the Imports (BoP, current US$) in 2006 in Pakistan to that in Philippines?
Provide a short and direct response. 0.72. What is the ratio of the Imports (BoP, current US$) in 2007 in Pakistan to that in Philippines?
Offer a very short reply. 0.69. What is the ratio of the Imports (BoP, current US$) in 2008 in Pakistan to that in Philippines?
Make the answer very short. 0.74. What is the ratio of the Imports (BoP, current US$) of 2005 in Panama to that in Philippines?
Your response must be concise. 0.24. What is the ratio of the Imports (BoP, current US$) of 2006 in Panama to that in Philippines?
Provide a short and direct response. 0.24. What is the ratio of the Imports (BoP, current US$) in 2007 in Panama to that in Philippines?
Offer a terse response. 0.27. What is the ratio of the Imports (BoP, current US$) in 2008 in Panama to that in Philippines?
Offer a very short reply. 0.28. What is the difference between the highest and the second highest Imports (BoP, current US$) in 2005?
Give a very brief answer. 3.48e+11. What is the difference between the highest and the second highest Imports (BoP, current US$) in 2006?
Give a very brief answer. 3.92e+11. What is the difference between the highest and the second highest Imports (BoP, current US$) in 2007?
Your answer should be compact. 4.67e+11. What is the difference between the highest and the second highest Imports (BoP, current US$) in 2008?
Provide a short and direct response. 5.31e+11. What is the difference between the highest and the lowest Imports (BoP, current US$) of 2005?
Your response must be concise. 3.89e+11. What is the difference between the highest and the lowest Imports (BoP, current US$) in 2006?
Ensure brevity in your answer.  4.38e+11. What is the difference between the highest and the lowest Imports (BoP, current US$) in 2007?
Your answer should be very brief. 5.17e+11. What is the difference between the highest and the lowest Imports (BoP, current US$) of 2008?
Provide a short and direct response. 5.90e+11. 